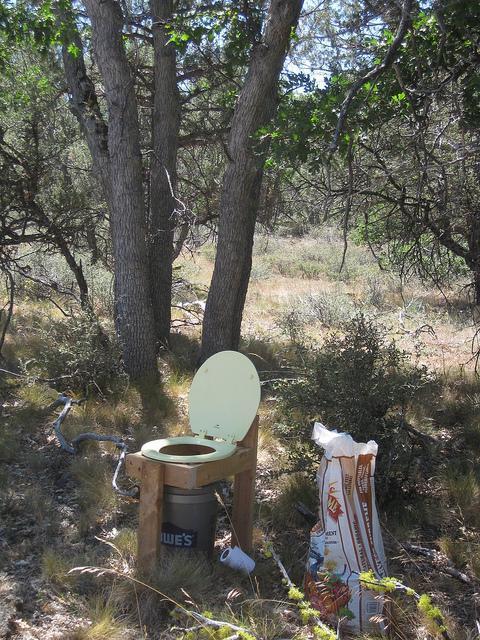How many laptop computers are visible in this image?
Give a very brief answer. 0. 